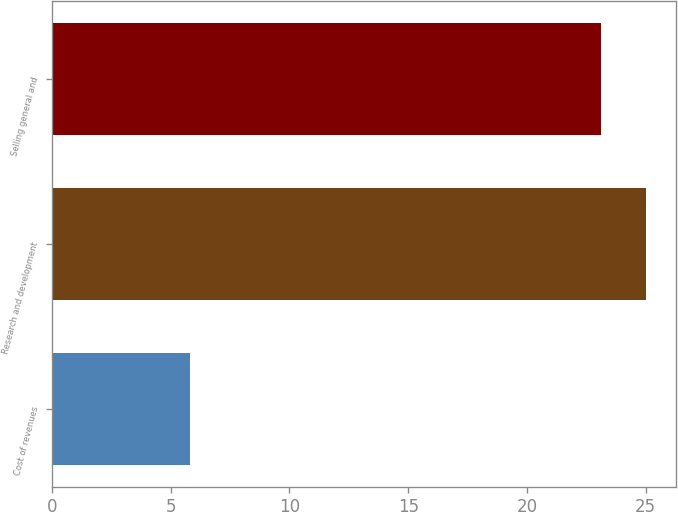Convert chart. <chart><loc_0><loc_0><loc_500><loc_500><bar_chart><fcel>Cost of revenues<fcel>Research and development<fcel>Selling general and<nl><fcel>5.8<fcel>25.02<fcel>23.1<nl></chart> 